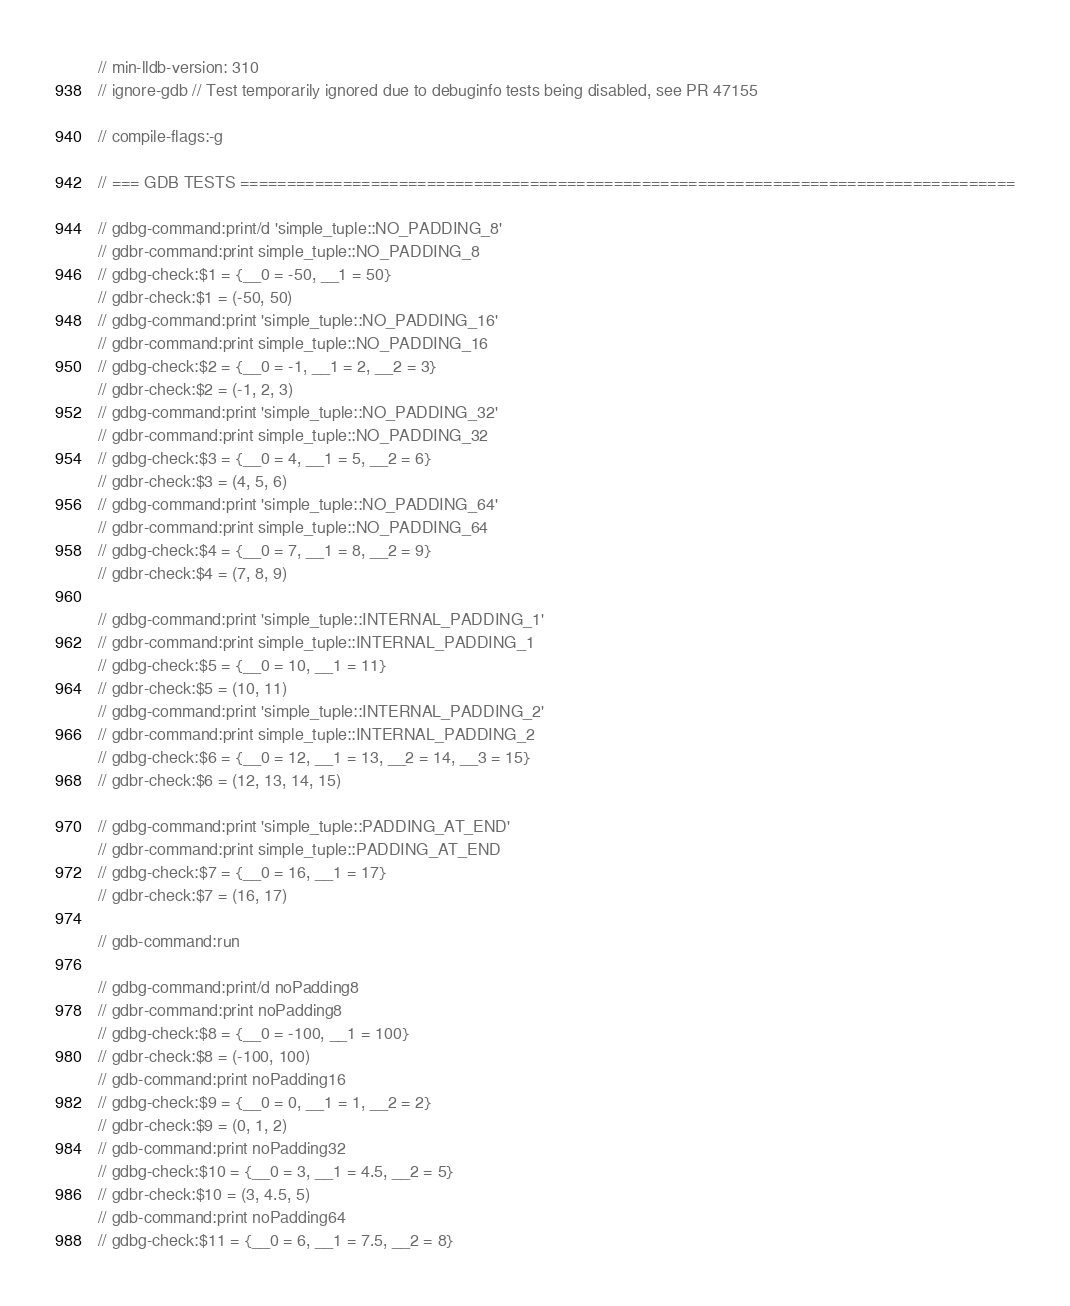<code> <loc_0><loc_0><loc_500><loc_500><_Rust_>// min-lldb-version: 310
// ignore-gdb // Test temporarily ignored due to debuginfo tests being disabled, see PR 47155

// compile-flags:-g

// === GDB TESTS ===================================================================================

// gdbg-command:print/d 'simple_tuple::NO_PADDING_8'
// gdbr-command:print simple_tuple::NO_PADDING_8
// gdbg-check:$1 = {__0 = -50, __1 = 50}
// gdbr-check:$1 = (-50, 50)
// gdbg-command:print 'simple_tuple::NO_PADDING_16'
// gdbr-command:print simple_tuple::NO_PADDING_16
// gdbg-check:$2 = {__0 = -1, __1 = 2, __2 = 3}
// gdbr-check:$2 = (-1, 2, 3)
// gdbg-command:print 'simple_tuple::NO_PADDING_32'
// gdbr-command:print simple_tuple::NO_PADDING_32
// gdbg-check:$3 = {__0 = 4, __1 = 5, __2 = 6}
// gdbr-check:$3 = (4, 5, 6)
// gdbg-command:print 'simple_tuple::NO_PADDING_64'
// gdbr-command:print simple_tuple::NO_PADDING_64
// gdbg-check:$4 = {__0 = 7, __1 = 8, __2 = 9}
// gdbr-check:$4 = (7, 8, 9)

// gdbg-command:print 'simple_tuple::INTERNAL_PADDING_1'
// gdbr-command:print simple_tuple::INTERNAL_PADDING_1
// gdbg-check:$5 = {__0 = 10, __1 = 11}
// gdbr-check:$5 = (10, 11)
// gdbg-command:print 'simple_tuple::INTERNAL_PADDING_2'
// gdbr-command:print simple_tuple::INTERNAL_PADDING_2
// gdbg-check:$6 = {__0 = 12, __1 = 13, __2 = 14, __3 = 15}
// gdbr-check:$6 = (12, 13, 14, 15)

// gdbg-command:print 'simple_tuple::PADDING_AT_END'
// gdbr-command:print simple_tuple::PADDING_AT_END
// gdbg-check:$7 = {__0 = 16, __1 = 17}
// gdbr-check:$7 = (16, 17)

// gdb-command:run

// gdbg-command:print/d noPadding8
// gdbr-command:print noPadding8
// gdbg-check:$8 = {__0 = -100, __1 = 100}
// gdbr-check:$8 = (-100, 100)
// gdb-command:print noPadding16
// gdbg-check:$9 = {__0 = 0, __1 = 1, __2 = 2}
// gdbr-check:$9 = (0, 1, 2)
// gdb-command:print noPadding32
// gdbg-check:$10 = {__0 = 3, __1 = 4.5, __2 = 5}
// gdbr-check:$10 = (3, 4.5, 5)
// gdb-command:print noPadding64
// gdbg-check:$11 = {__0 = 6, __1 = 7.5, __2 = 8}</code> 